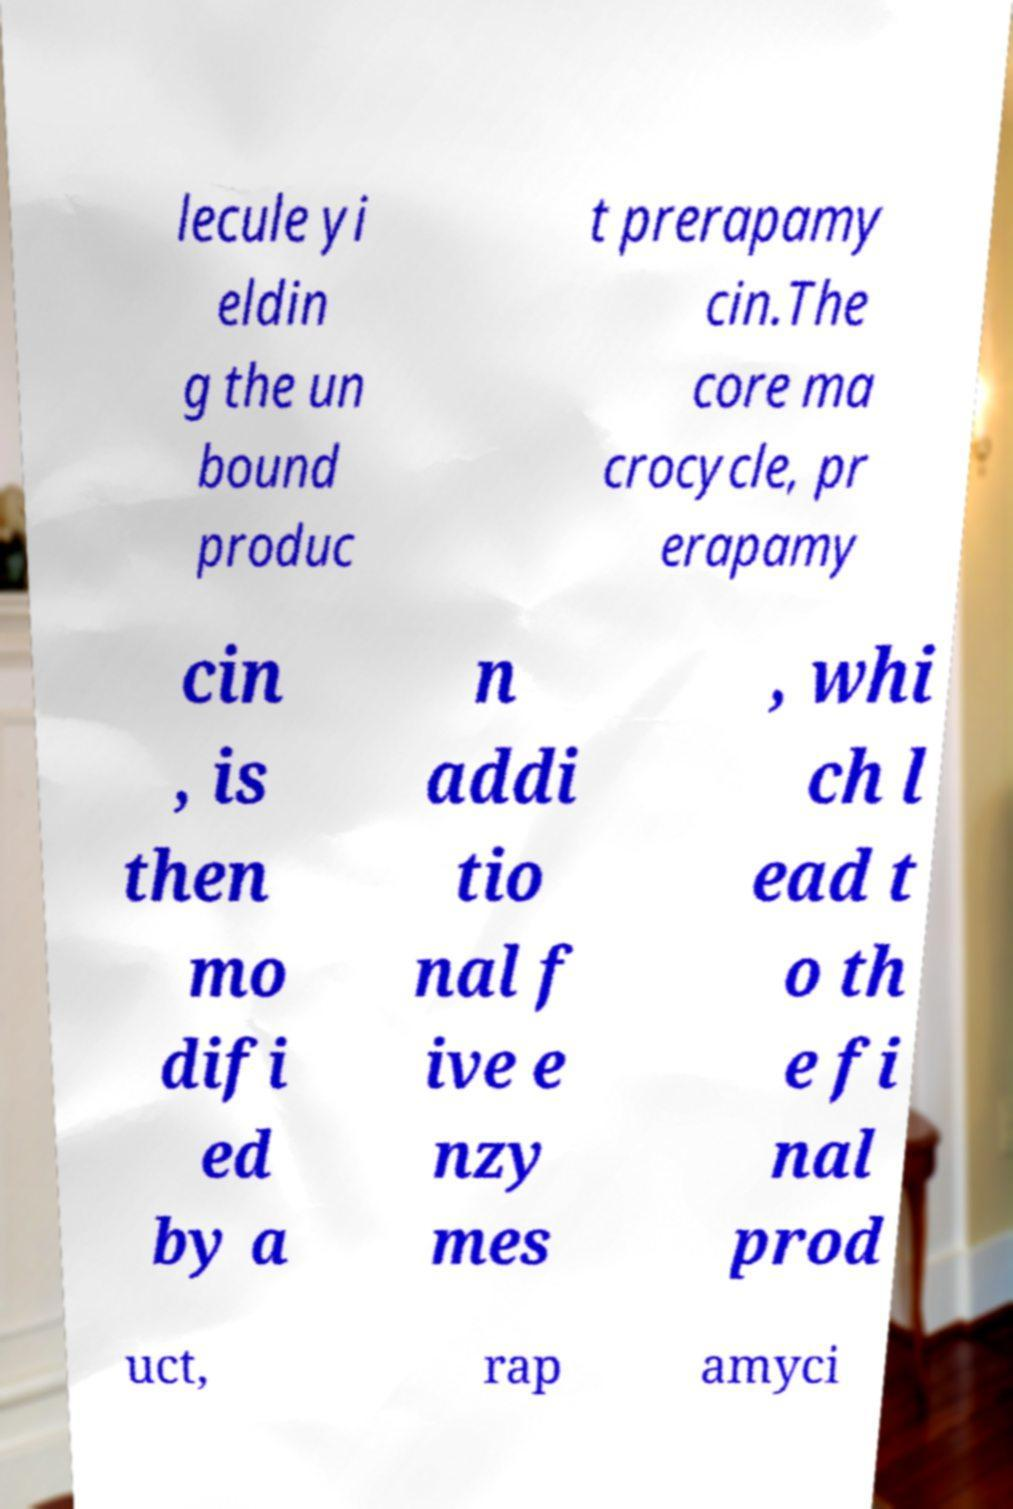What messages or text are displayed in this image? I need them in a readable, typed format. lecule yi eldin g the un bound produc t prerapamy cin.The core ma crocycle, pr erapamy cin , is then mo difi ed by a n addi tio nal f ive e nzy mes , whi ch l ead t o th e fi nal prod uct, rap amyci 